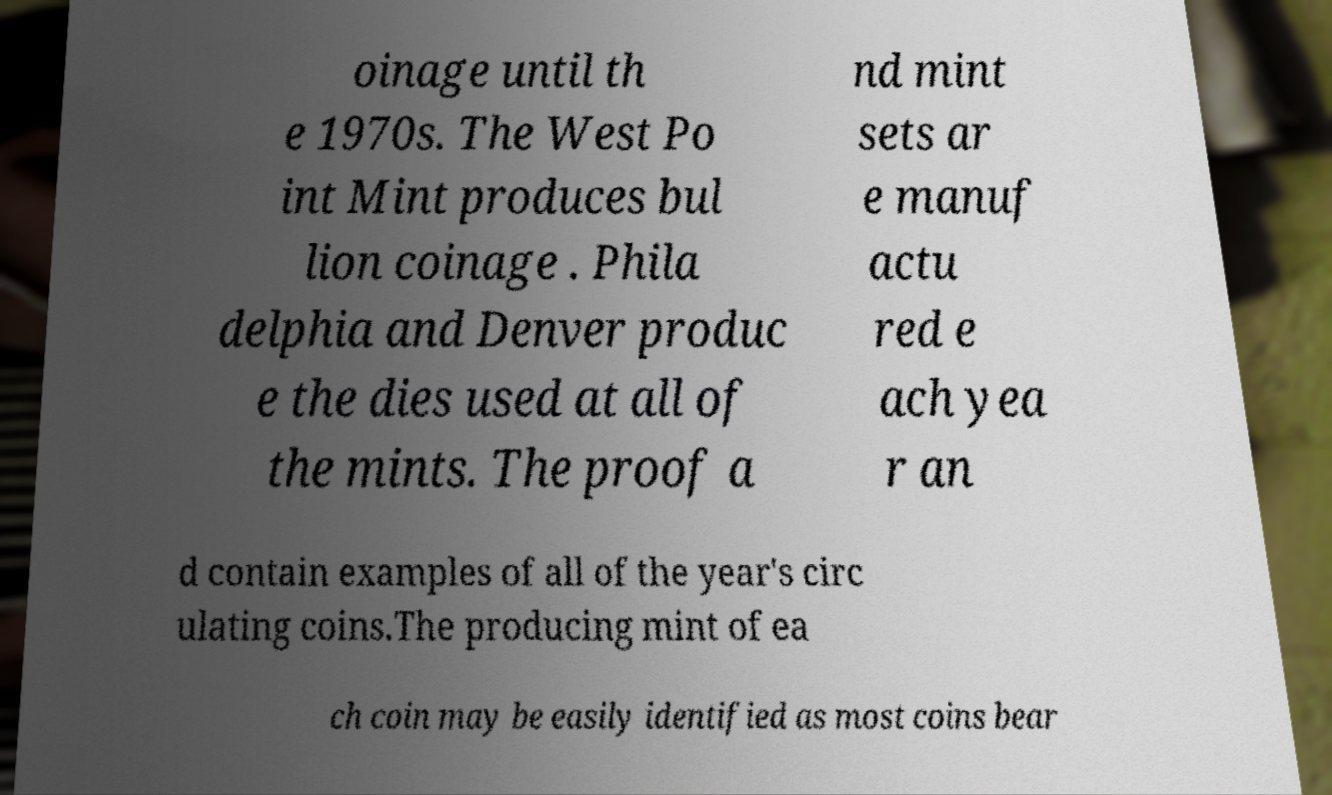There's text embedded in this image that I need extracted. Can you transcribe it verbatim? oinage until th e 1970s. The West Po int Mint produces bul lion coinage . Phila delphia and Denver produc e the dies used at all of the mints. The proof a nd mint sets ar e manuf actu red e ach yea r an d contain examples of all of the year's circ ulating coins.The producing mint of ea ch coin may be easily identified as most coins bear 